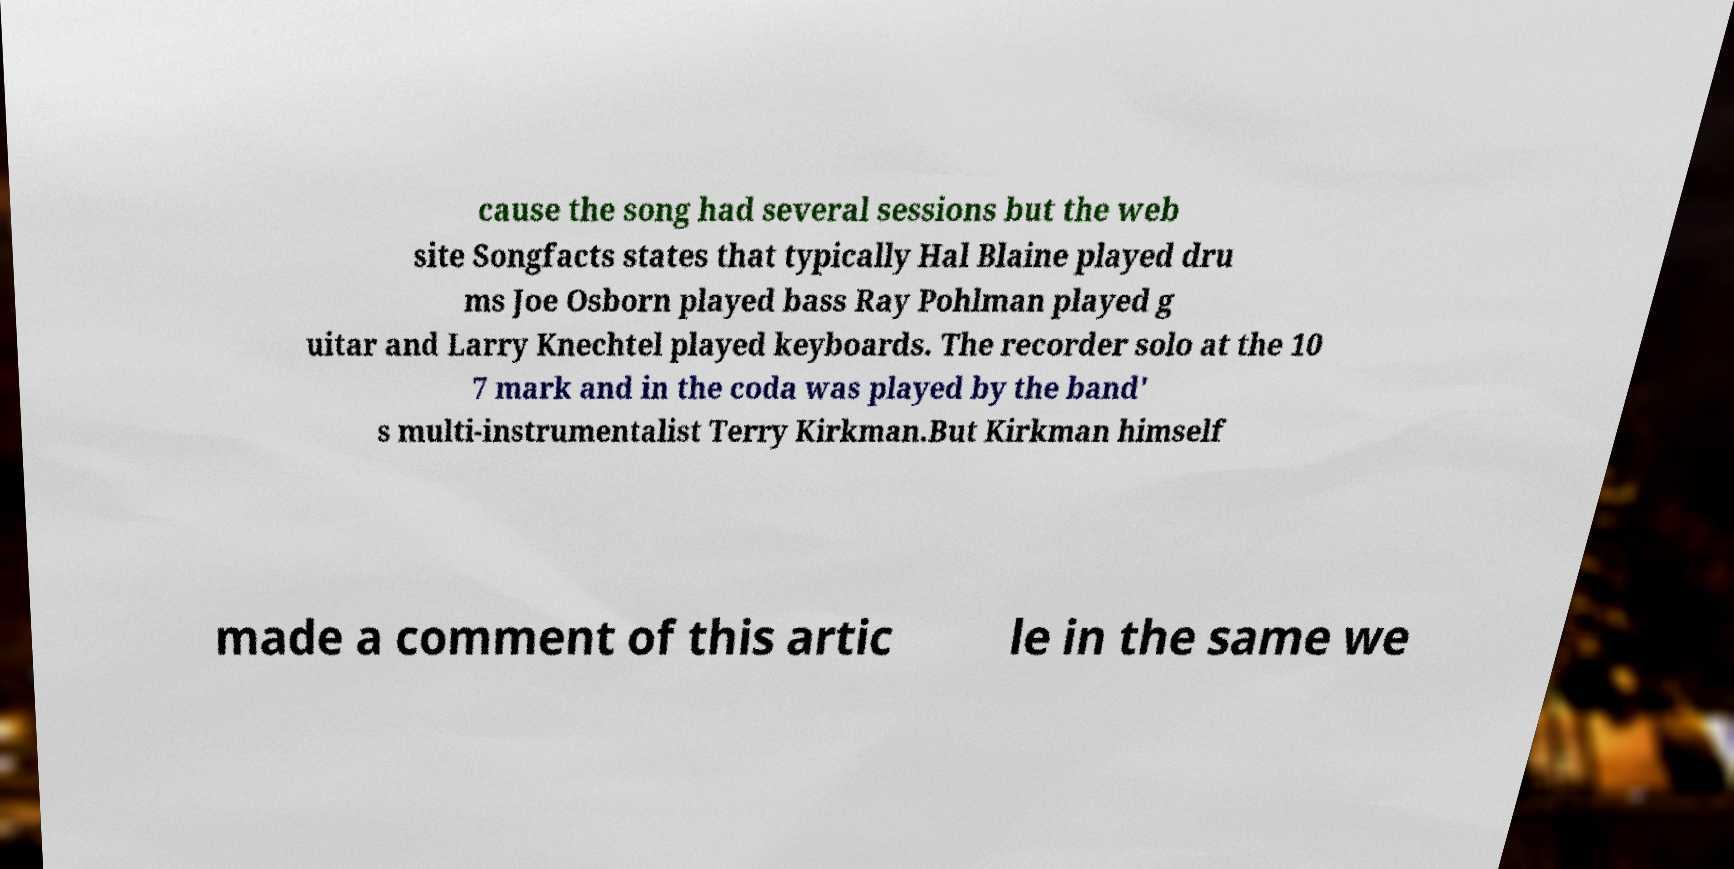Can you accurately transcribe the text from the provided image for me? cause the song had several sessions but the web site Songfacts states that typically Hal Blaine played dru ms Joe Osborn played bass Ray Pohlman played g uitar and Larry Knechtel played keyboards. The recorder solo at the 10 7 mark and in the coda was played by the band' s multi-instrumentalist Terry Kirkman.But Kirkman himself made a comment of this artic le in the same we 